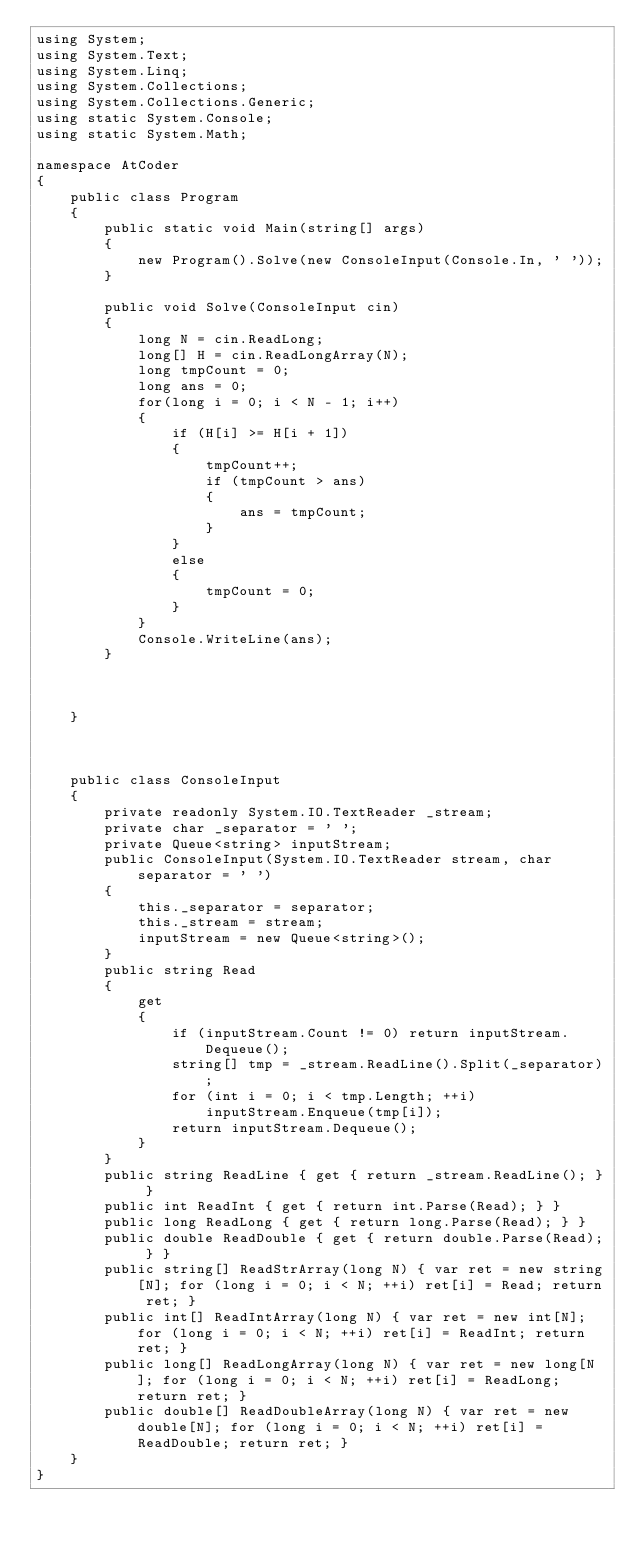<code> <loc_0><loc_0><loc_500><loc_500><_C#_>using System;
using System.Text;
using System.Linq;
using System.Collections;
using System.Collections.Generic;
using static System.Console;
using static System.Math;

namespace AtCoder
{
    public class Program
    {
        public static void Main(string[] args)
        {
            new Program().Solve(new ConsoleInput(Console.In, ' '));
        }

        public void Solve(ConsoleInput cin)
        {
            long N = cin.ReadLong;
            long[] H = cin.ReadLongArray(N);
            long tmpCount = 0;
            long ans = 0;
            for(long i = 0; i < N - 1; i++)
            {
                if (H[i] >= H[i + 1])
                {
                    tmpCount++;
                    if (tmpCount > ans)
                    {
                        ans = tmpCount;
                    }
                }
                else
                {
                    tmpCount = 0;
                }
            }
            Console.WriteLine(ans);
        }
            

                
    }  
            


    public class ConsoleInput
    {
        private readonly System.IO.TextReader _stream;
        private char _separator = ' ';
        private Queue<string> inputStream;
        public ConsoleInput(System.IO.TextReader stream, char separator = ' ')
        {
            this._separator = separator;
            this._stream = stream;
            inputStream = new Queue<string>();
        }
        public string Read
        {
            get
            {
                if (inputStream.Count != 0) return inputStream.Dequeue();
                string[] tmp = _stream.ReadLine().Split(_separator);
                for (int i = 0; i < tmp.Length; ++i)
                    inputStream.Enqueue(tmp[i]);
                return inputStream.Dequeue();
            }
        }
        public string ReadLine { get { return _stream.ReadLine(); } }
        public int ReadInt { get { return int.Parse(Read); } }
        public long ReadLong { get { return long.Parse(Read); } }
        public double ReadDouble { get { return double.Parse(Read); } }
        public string[] ReadStrArray(long N) { var ret = new string[N]; for (long i = 0; i < N; ++i) ret[i] = Read; return ret; }
        public int[] ReadIntArray(long N) { var ret = new int[N]; for (long i = 0; i < N; ++i) ret[i] = ReadInt; return ret; }
        public long[] ReadLongArray(long N) { var ret = new long[N]; for (long i = 0; i < N; ++i) ret[i] = ReadLong; return ret; }
        public double[] ReadDoubleArray(long N) { var ret = new double[N]; for (long i = 0; i < N; ++i) ret[i] = ReadDouble; return ret; }
    }
}
</code> 